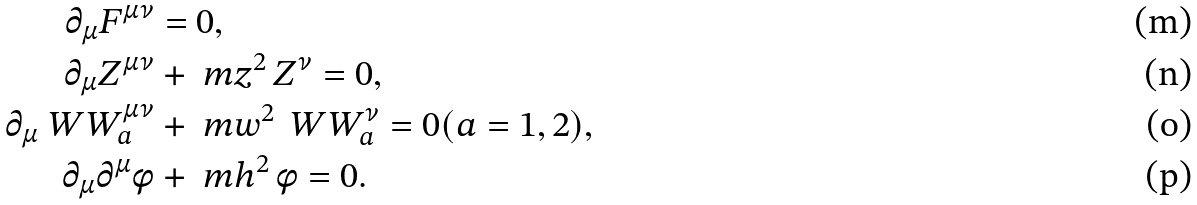<formula> <loc_0><loc_0><loc_500><loc_500>\partial _ { \mu } { F } ^ { \mu \nu } & = 0 , \\ \partial _ { \mu } Z ^ { \mu \nu } & + \ m z ^ { 2 } \, Z ^ { \nu } = 0 , \\ \partial _ { \mu } \ W W _ { a } ^ { \mu \nu } & + \ m w ^ { 2 } \, \ W W _ { a } ^ { \nu } = 0 ( a = 1 , 2 ) , \\ \partial _ { \mu } \partial ^ { \mu } \phi & + \ m h ^ { 2 } \, \phi = 0 .</formula> 